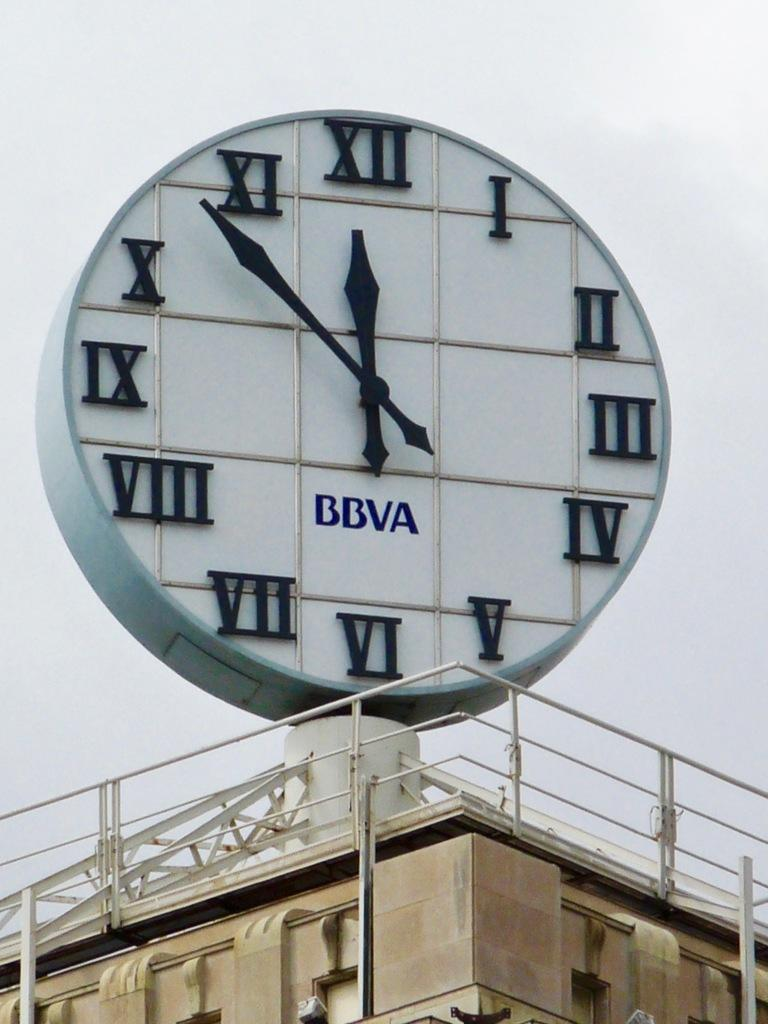<image>
Give a short and clear explanation of the subsequent image. Large clock with roman numerals and BBVA in blue letters. 